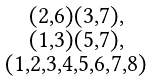<formula> <loc_0><loc_0><loc_500><loc_500>\begin{smallmatrix} ( 2 , 6 ) ( 3 , 7 ) , \\ ( 1 , 3 ) ( 5 , 7 ) , \\ ( 1 , 2 , 3 , 4 , 5 , 6 , 7 , 8 ) \end{smallmatrix}</formula> 